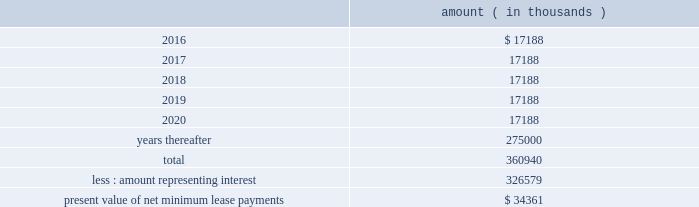Entergy corporation and subsidiaries notes to financial statements as of december 31 , 2015 , system energy , in connection with the grand gulf sale and leaseback transactions , had future minimum lease payments ( reflecting an implicit rate of 5.13% ( 5.13 % ) ) that are recorded as long-term debt , as follows : amount ( in thousands ) .
Note 11 .
Retirement , other postretirement benefits , and defined contribution qualified pension plans entergy has nine qualified pension plans covering substantially all employees .
The 201centergy corporation retirement plan for non-bargaining employees , 201d 201centergy corporation retirement plan for bargaining employees , 201d 201centergy corporation retirement plan ii for non-bargaining employees , 201d 201centergy corporation retirement plan ii for bargaining employees , 201d 201centergy corporation retirement plan iv for non-bargaining employees , 201d and 201centergy corporation retirement plan iv for bargaining employees 201d are non-contributory final average pay plans and provide pension benefits that are based on employees 2019 credited service and compensation during employment .
The 201centergy corporation retirement plan iii 201d is a final average pay plan that provides pension benefits that are based on employees 2019 credited service and compensation during the final years before retirement and includes a mandatory employee contribution of 3% ( 3 % ) of earnings during the first 10 years of plan participation , and allows voluntary contributions from 1% ( 1 % ) to 10% ( 10 % ) of earnings for a limited group of employees .
Non-bargaining employees whose most recent date of hire is after june 30 , 2014 participate in the 201centergy corporation cash balance plan for non-bargaining employees . 201d certain bargaining employees hired or rehired after june 30 , 2014 , or such later date provided for in their applicable collective bargaining agreements , participate in the 201centergy corporation cash balance plan for bargaining employees . 201d the registrant subsidiaries participate in these four plans : 201centergy corporation retirement plan for non-bargaining employees , 201d 201centergy corporation retirement plan for bargaining employees , 201d 201centergy corporation cash balance plan for non-bargaining employees , 201d and 201centergy cash balance plan for bargaining employees . 201d .
In 2015 what was the percent of the total future minimum lease payments that was due in 2018? 
Computations: (17188 / 360940)
Answer: 0.04762. 